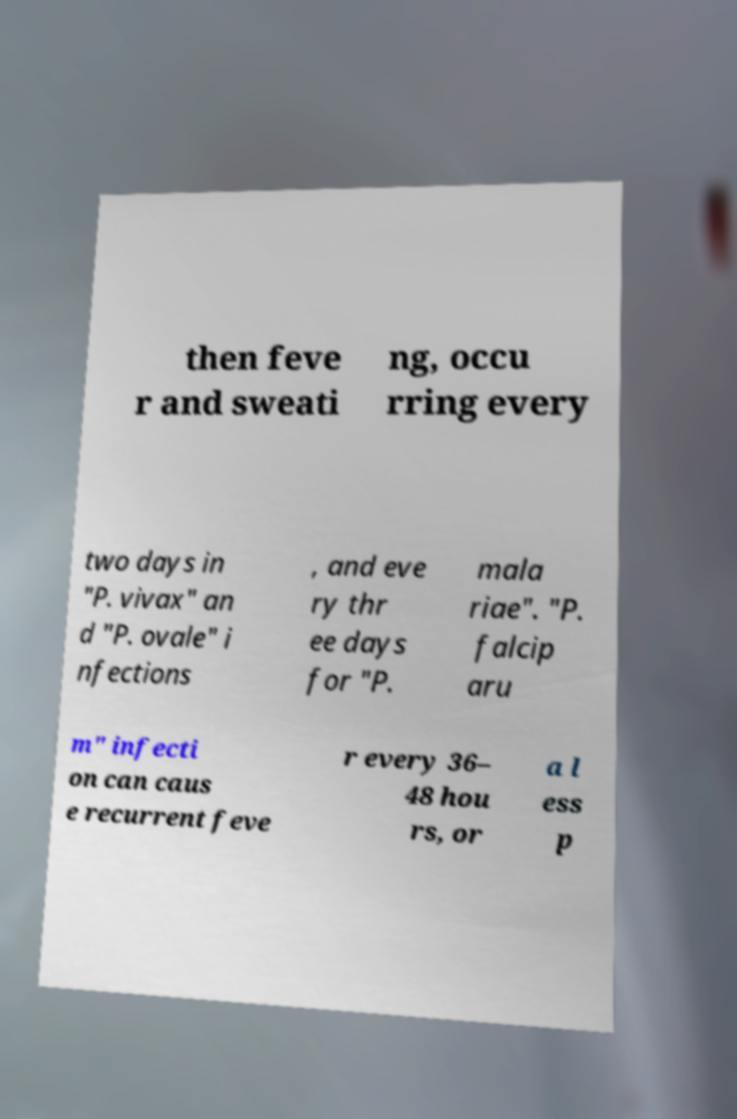Can you read and provide the text displayed in the image?This photo seems to have some interesting text. Can you extract and type it out for me? then feve r and sweati ng, occu rring every two days in "P. vivax" an d "P. ovale" i nfections , and eve ry thr ee days for "P. mala riae". "P. falcip aru m" infecti on can caus e recurrent feve r every 36– 48 hou rs, or a l ess p 